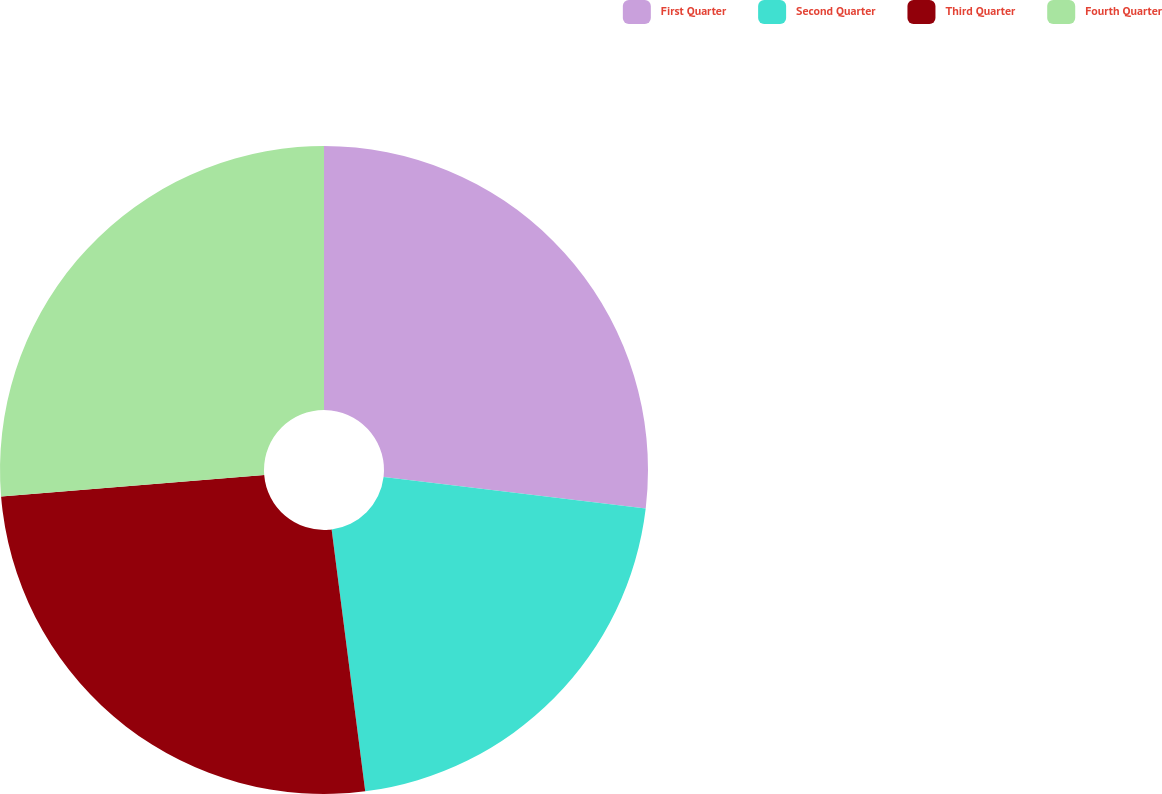Convert chart. <chart><loc_0><loc_0><loc_500><loc_500><pie_chart><fcel>First Quarter<fcel>Second Quarter<fcel>Third Quarter<fcel>Fourth Quarter<nl><fcel>26.89%<fcel>21.08%<fcel>25.73%<fcel>26.3%<nl></chart> 